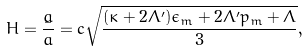Convert formula to latex. <formula><loc_0><loc_0><loc_500><loc_500>H = \frac { \dot { a } } { a } = c \sqrt { \frac { ( \kappa + 2 \Lambda ^ { \prime } ) \epsilon _ { m } + 2 \Lambda ^ { \prime } p _ { m } + \Lambda } { 3 } } ,</formula> 